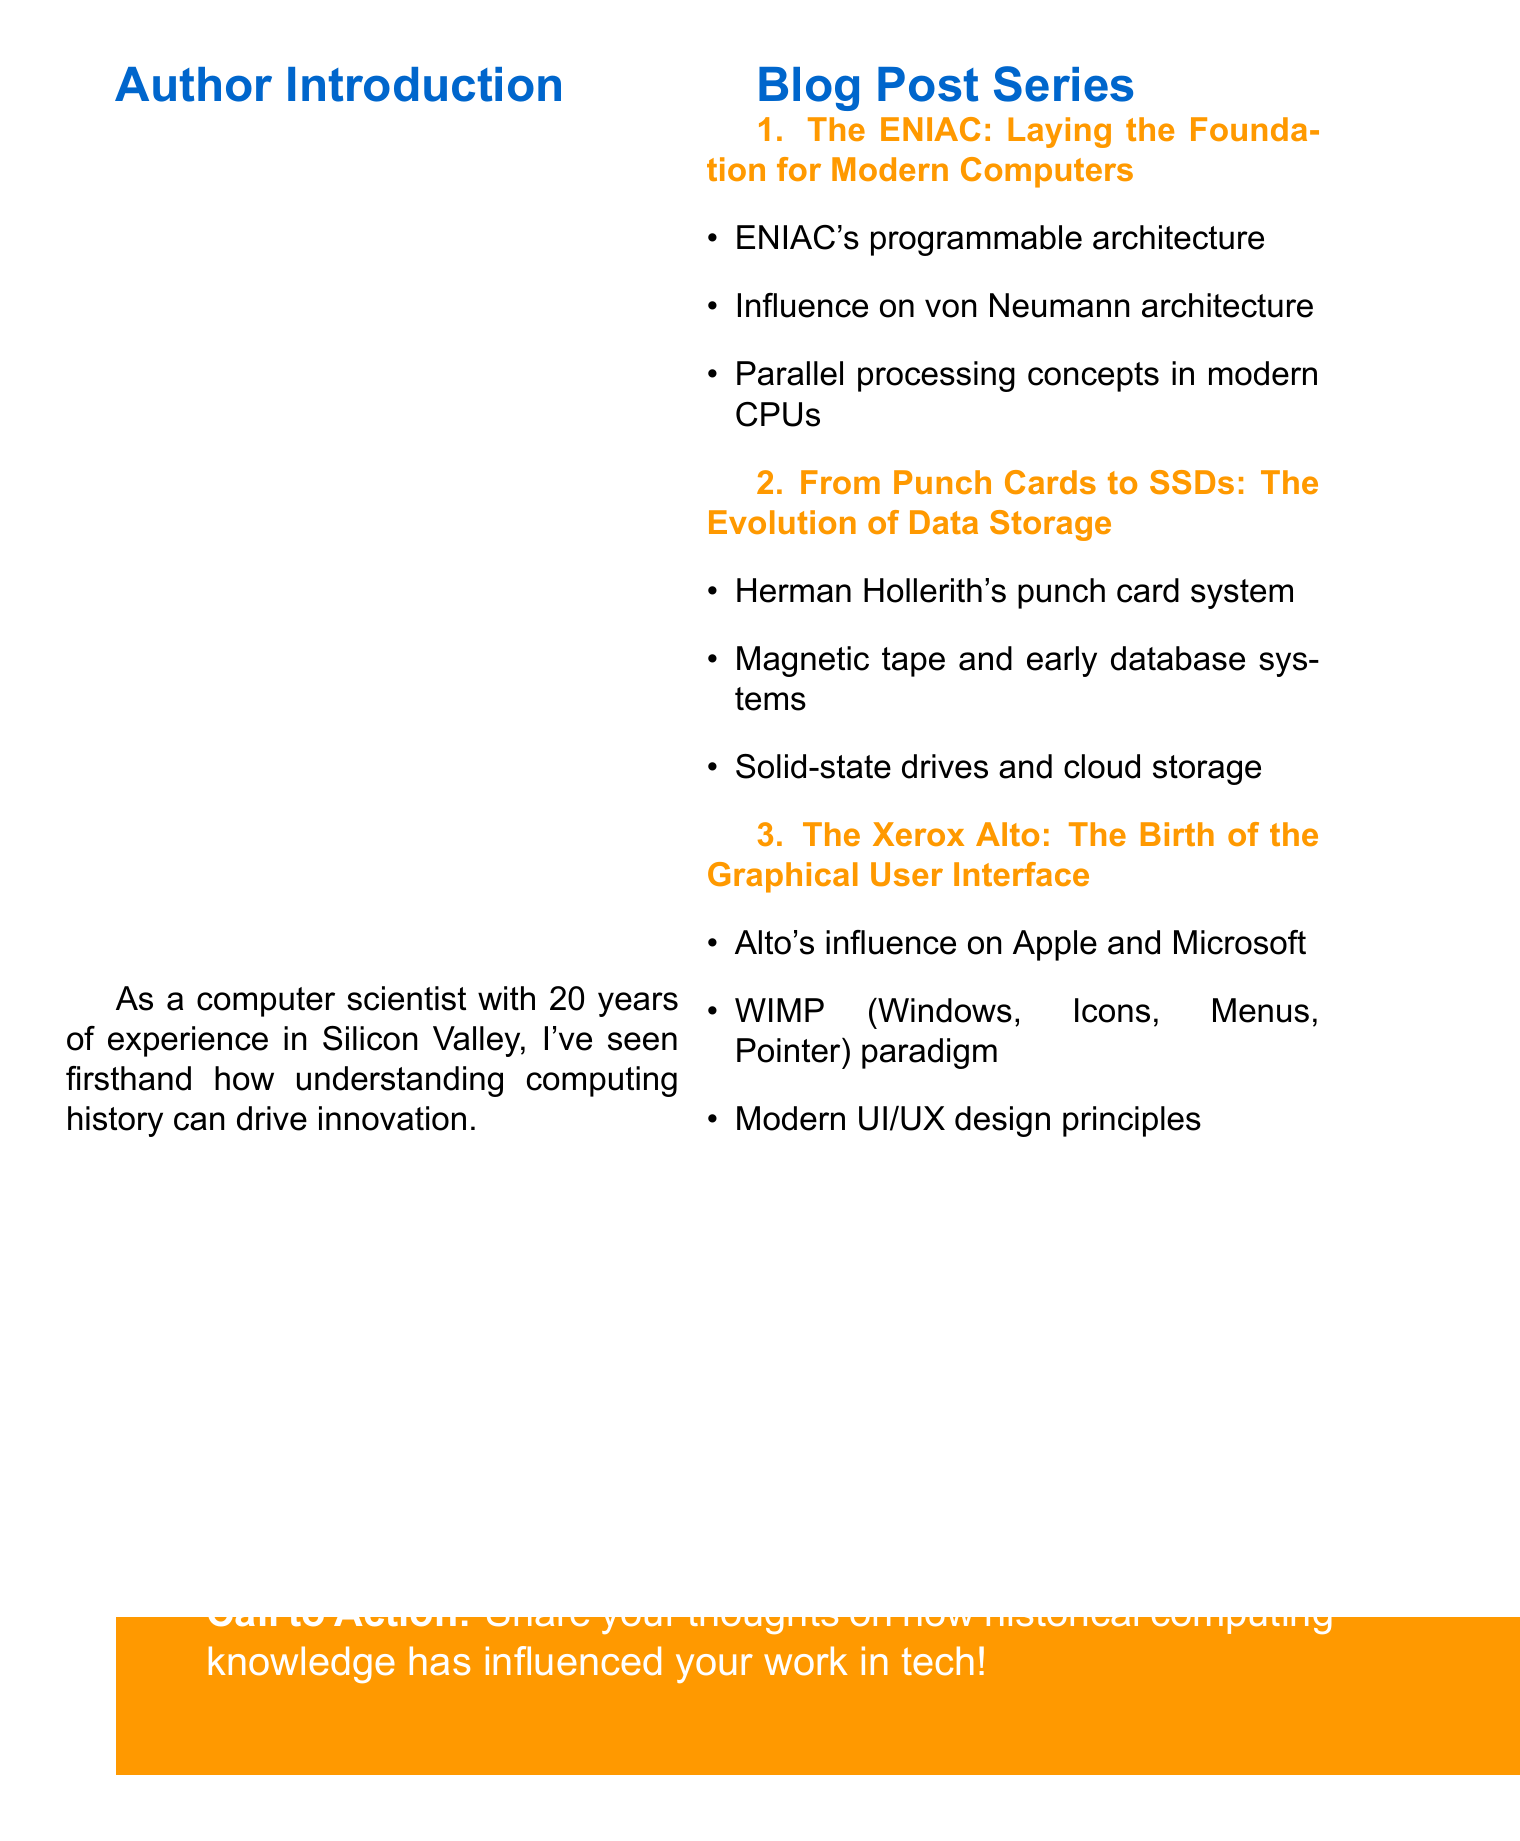What is the series title? The series title is the main heading of the document, outlining the theme of the blog post series.
Answer: Historical Computing Devices: Shaping Modern Tech Who is the author? The author is introduced early in the document and is a computer scientist with significant experience.
Answer: A computer scientist What is the first blog post title? The first blog post title is specified in the list of blog posts, marking the beginning of the series.
Answer: The ENIAC: Laying the Foundation for Modern Computers What is one key point of the second blog post? The key points of the second blog post outline its main topics of discussion.
Answer: Herman Hollerith's punch card system How many blog posts are included in the series? The number of blog posts can be counted from the list provided in the document.
Answer: Three What principle is highlighted in the third blog post? The third blog post discusses modern design concepts influenced by historical devices.
Answer: Modern UI/UX design principles What is the conclusion summarized in the document? The conclusion provides an overall reflection on the significance of historical computing devices in modern technology.
Answer: Understanding these historical devices helps us appreciate the foundations of modern technology and inspires future innovations in the tech industry What is the call to action? The call to action invites readers to engage with the content and share their own experiences.
Answer: Share your thoughts on how historical computing knowledge has influenced your work in tech! 